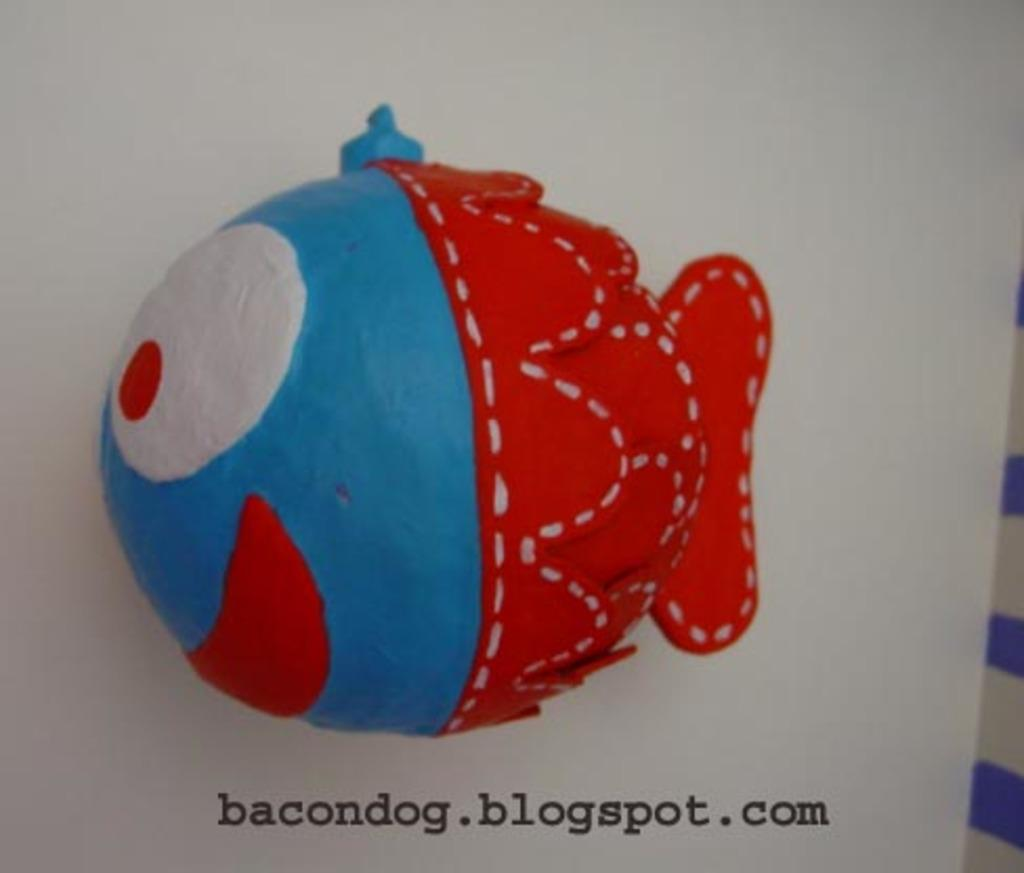What shape is the object in the image? The object is in the shape of a fish. What colors can be seen on the fish? The fish has blue and red colors. Is there any text visible on the object? Yes, there is a website name at the bottom of the object. What grade of heat is the fish object emitting in the image? The fish object is not emitting heat, as it is an inanimate object and not a source of heat. 